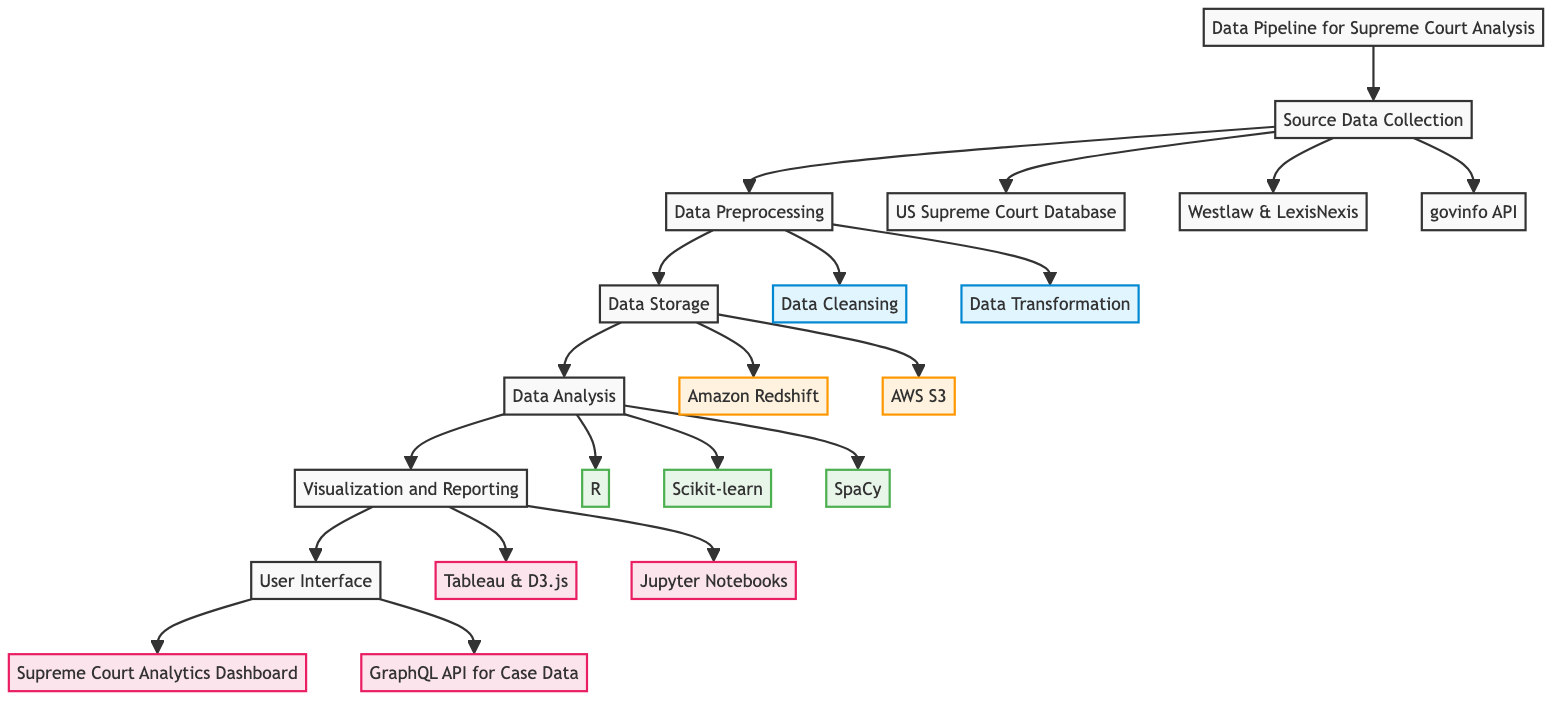What are the sources for data collection? The diagram indicates three sources for data collection: US Supreme Court Database, Westlaw & LexisNexis, and govinfo API. These items are connected to the node representing source data collection.
Answer: US Supreme Court Database, Westlaw & LexisNexis, govinfo API How many stages are there in the data pipeline? By reviewing the flowchart, I can identify six main stages: Source Data Collection, Data Preprocessing, Data Storage, Data Analysis, Visualization and Reporting, and User Interface.
Answer: 6 Which storage solutions are utilized? The diagram shows two storage solutions linked to Data Storage: Amazon Redshift and AWS S3, indicating the choices made for data management.
Answer: Amazon Redshift, AWS S3 What type of analysis is performed on the data? According to the diagram, the types of analysis mentioned are Statistical Analysis, Machine Learning, and Natural Language Processing, all of which fall under the Data Analysis stage.
Answer: Statistical Analysis, Machine Learning, Natural Language Processing What tools are used for reporting? The flowchart indicates that Jupyter Notebooks is the reporting tool utilized in the Visualization and Reporting stage. This is specified as a standalone output connected to the reporting process.
Answer: Jupyter Notebooks What connects Data Preprocessing and Data Storage? In the diagram, Data Preprocessing leads directly to Data Storage, indicating that the output of the preprocessing stage feeds directly into the storage stage of the pipeline.
Answer: Data Preprocessing → Data Storage How are visualization tools categorized? The diagram lists Tableau and D3.js as visualization tools, which are grouped under the Visualization and Reporting stage, thus indicating that both tools serve this purpose.
Answer: Tableau, D3.js Which user interface elements are mentioned? The User Interface node lists two elements: Supreme Court Analytics Dashboard and GraphQL API for Case Data, which represent the end-user access points to the processed data.
Answer: Supreme Court Analytics Dashboard, GraphQL API for Case Data Which process precedes Data Analysis? The flowchart illustrates that Data Storage directly precedes Data Analysis, indicating that only after data has been stored can analysis be performed.
Answer: Data Storage 